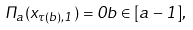<formula> <loc_0><loc_0><loc_500><loc_500>\Pi _ { a } ( x _ { \tau ( b ) , 1 } ) = 0 b \in [ a - 1 ] ,</formula> 